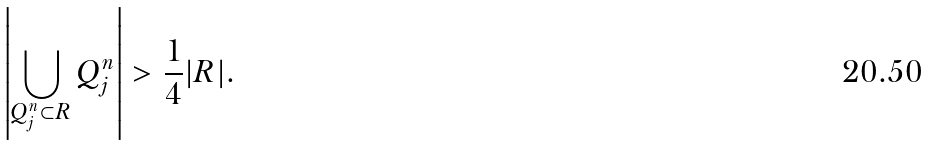Convert formula to latex. <formula><loc_0><loc_0><loc_500><loc_500>\left | \bigcup _ { Q _ { j } ^ { n } \subset R } Q _ { j } ^ { n } \right | > \frac { 1 } { 4 } | R | .</formula> 